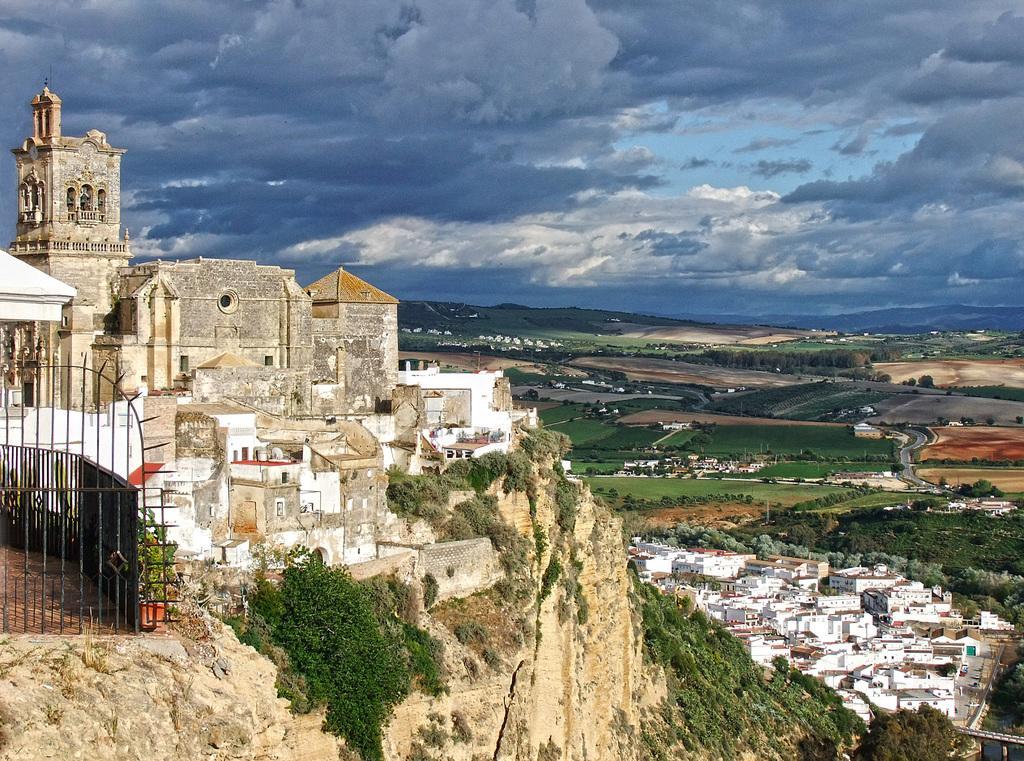Describe this image in one or two sentences. In this image we can see sky with clouds, castle, buildings, iron grill, hill, creepers, ground, trees and water. 